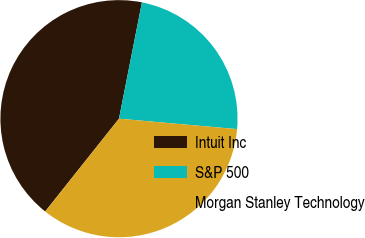Convert chart to OTSL. <chart><loc_0><loc_0><loc_500><loc_500><pie_chart><fcel>Intuit Inc<fcel>S&P 500<fcel>Morgan Stanley Technology<nl><fcel>42.41%<fcel>23.3%<fcel>34.29%<nl></chart> 